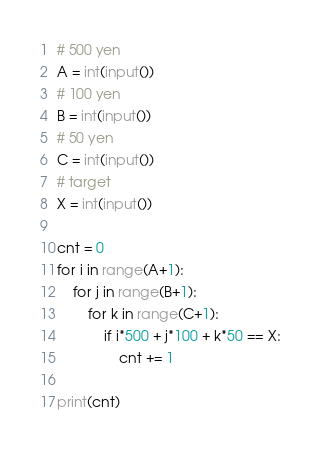Convert code to text. <code><loc_0><loc_0><loc_500><loc_500><_Python_># 500 yen
A = int(input())
# 100 yen
B = int(input())
# 50 yen
C = int(input())
# target
X = int(input())

cnt = 0
for i in range(A+1):
    for j in range(B+1):
        for k in range(C+1):
            if i*500 + j*100 + k*50 == X:
                cnt += 1

print(cnt)</code> 